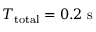Convert formula to latex. <formula><loc_0><loc_0><loc_500><loc_500>T _ { t o t a l } = 0 . 2 s</formula> 